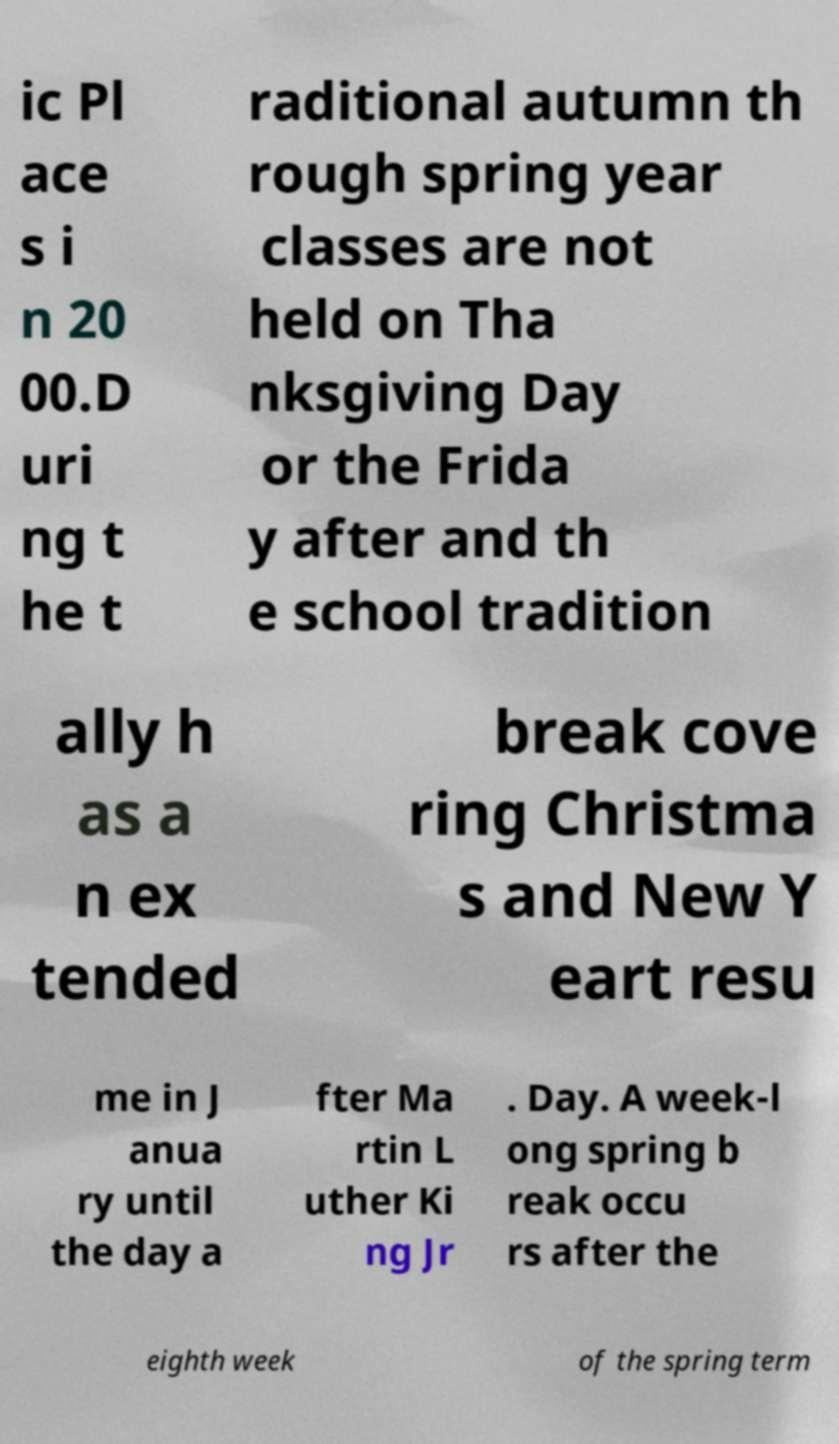There's text embedded in this image that I need extracted. Can you transcribe it verbatim? ic Pl ace s i n 20 00.D uri ng t he t raditional autumn th rough spring year classes are not held on Tha nksgiving Day or the Frida y after and th e school tradition ally h as a n ex tended break cove ring Christma s and New Y eart resu me in J anua ry until the day a fter Ma rtin L uther Ki ng Jr . Day. A week-l ong spring b reak occu rs after the eighth week of the spring term 